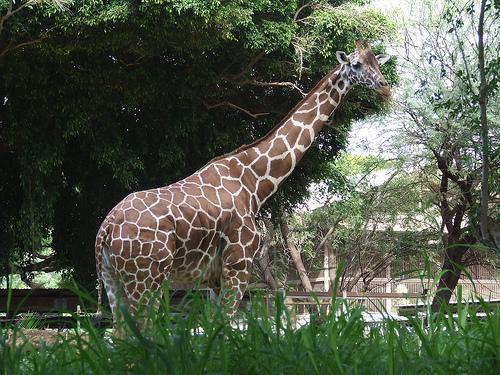How many giraffe are shown?
Give a very brief answer. 1. How many trees are to the right of the girraffe?
Give a very brief answer. 1. 